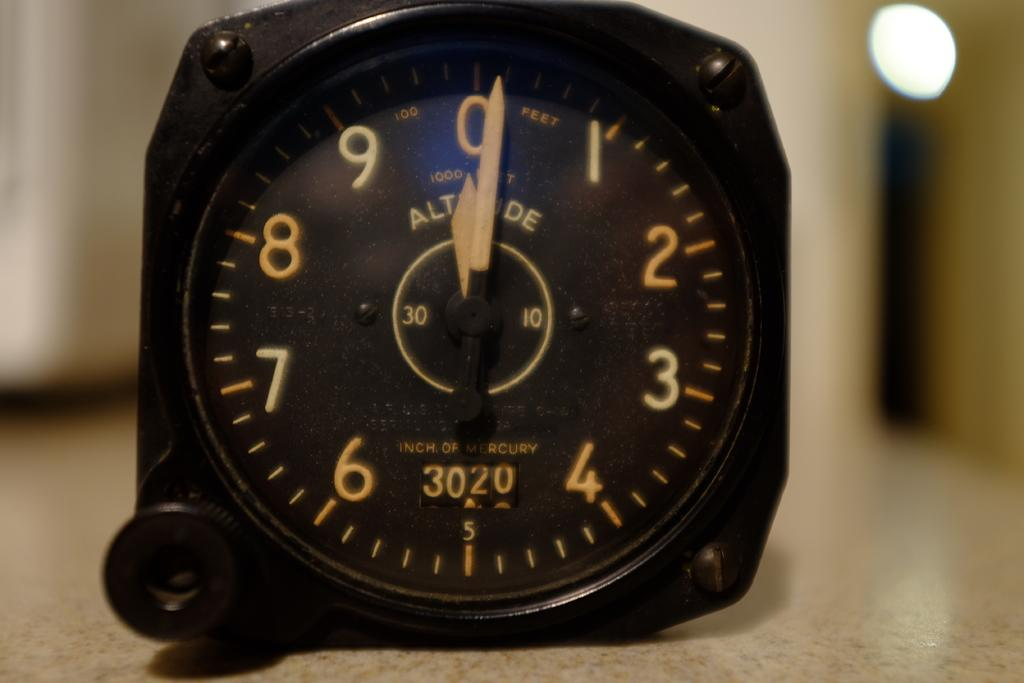<image>
Give a short and clear explanation of the subsequent image. A black watch showing 3020 inches of mercury on the bottom half. 